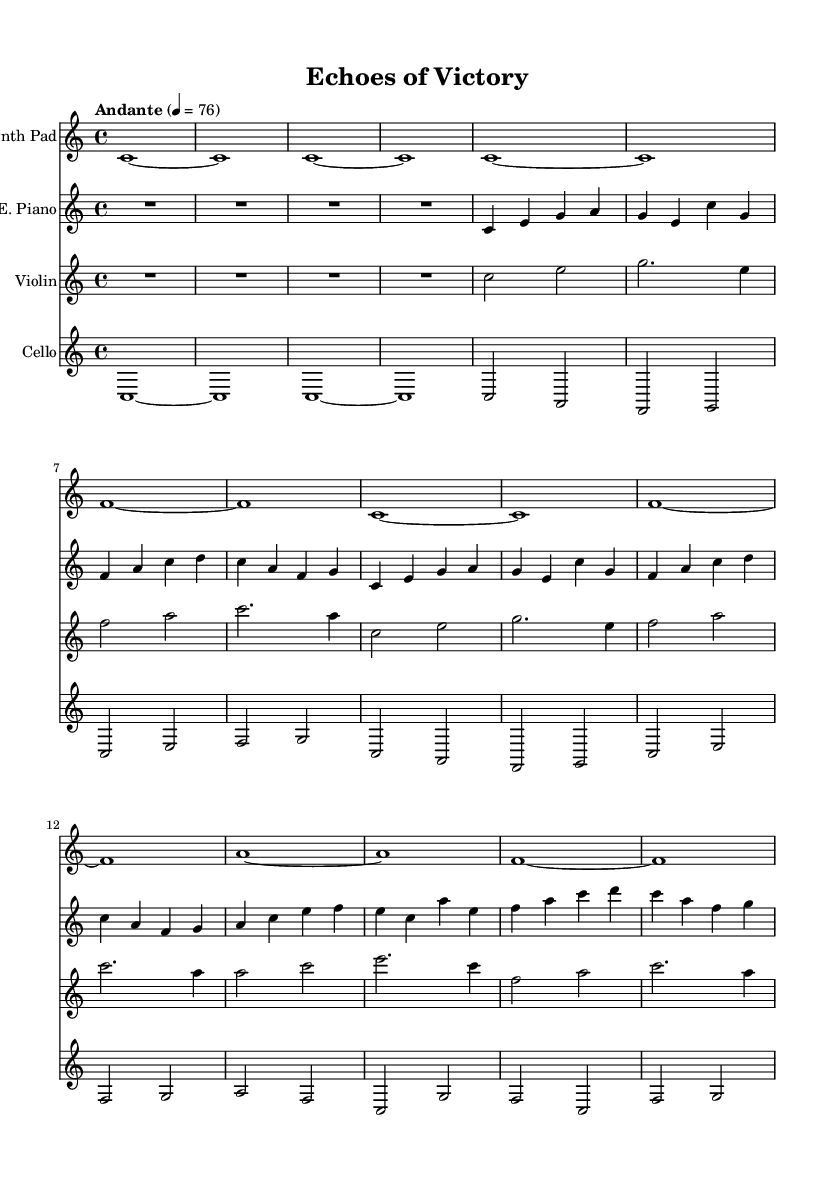What is the key signature of this music? The key signature is C major, which has no sharps or flats indicated in the music.
Answer: C major What is the time signature of this music? The time signature is indicated as 4/4, meaning there are four beats in each measure.
Answer: 4/4 What is the tempo marking of this piece? The tempo marking is "Andante," which means a moderately slow tempo. It is set to a quarter note equals 76 beats per minute.
Answer: Andante How many distinct instruments are featured in this piece? There are four distinct instruments featured: Synth Pad, Electric Piano, Violin, and Cello.
Answer: Four Which section starts the piece? The piece starts with an "Intro" section, as labeled in the music.
Answer: Intro What thematic structure is introduced after the Intro? The Main Theme A follows the Intro, as indicated in the score.
Answer: Main Theme A During which section do we find a shift to the use of A and F notes prominently? In the Bridge section, there is a prominent use of A and F notes, providing a contrast to the earlier sections.
Answer: Bridge 